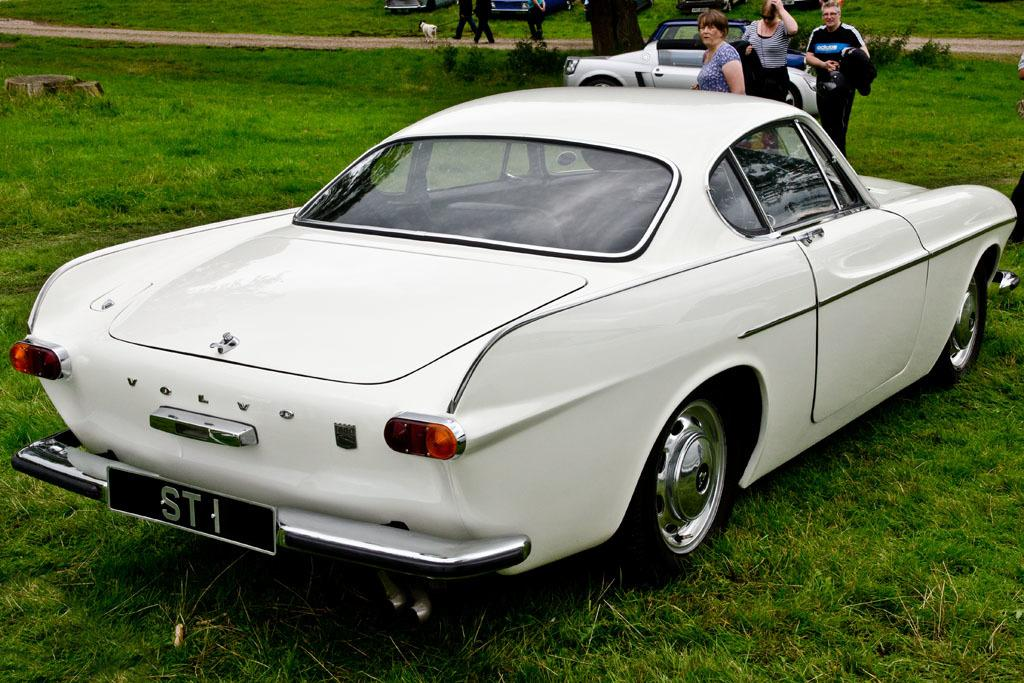What can be seen in the image? There are cars and people standing on the ground in the image. Are there any animals visible in the image? Yes, there is a dog visible in the background of the image. What else can be seen in the background of the image? There are people walking on a path in the background of the image. What verse is being recited by the people in the image? There is no indication in the image that people are reciting a verse. The image only shows cars, people standing on the ground, a dog, and people walking on a path in the background. 